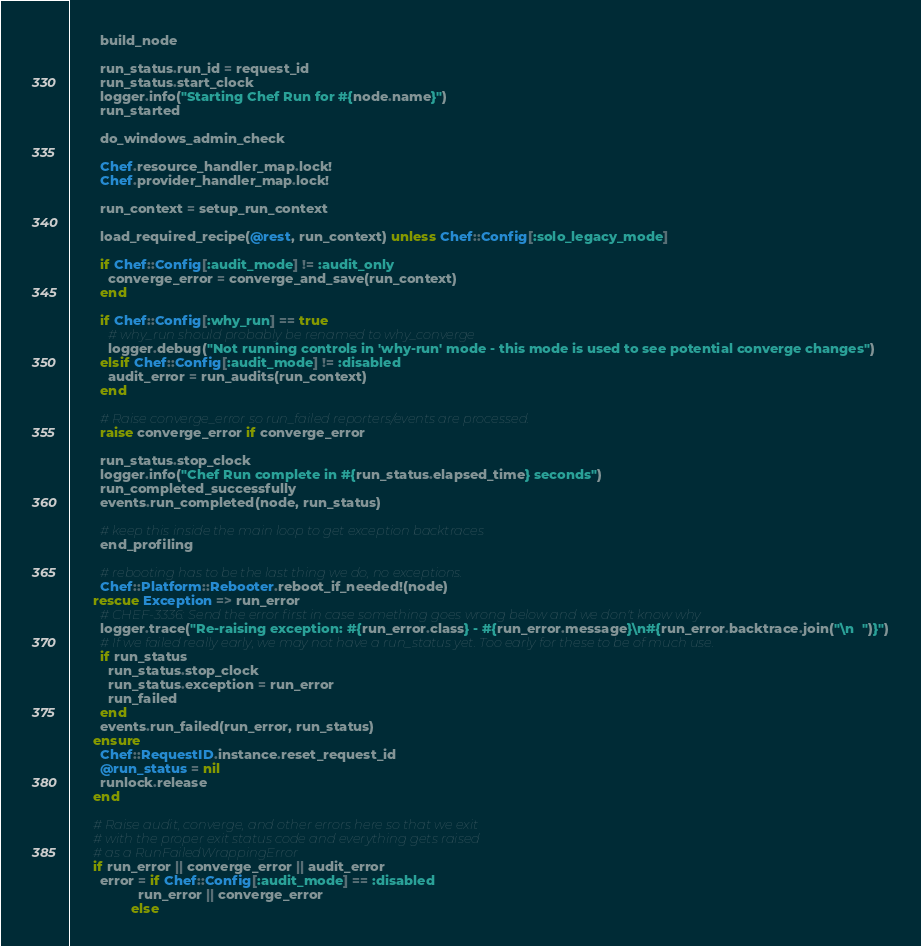Convert code to text. <code><loc_0><loc_0><loc_500><loc_500><_Ruby_>
        build_node

        run_status.run_id = request_id
        run_status.start_clock
        logger.info("Starting Chef Run for #{node.name}")
        run_started

        do_windows_admin_check

        Chef.resource_handler_map.lock!
        Chef.provider_handler_map.lock!

        run_context = setup_run_context

        load_required_recipe(@rest, run_context) unless Chef::Config[:solo_legacy_mode]

        if Chef::Config[:audit_mode] != :audit_only
          converge_error = converge_and_save(run_context)
        end

        if Chef::Config[:why_run] == true
          # why_run should probably be renamed to why_converge
          logger.debug("Not running controls in 'why-run' mode - this mode is used to see potential converge changes")
        elsif Chef::Config[:audit_mode] != :disabled
          audit_error = run_audits(run_context)
        end

        # Raise converge_error so run_failed reporters/events are processed.
        raise converge_error if converge_error

        run_status.stop_clock
        logger.info("Chef Run complete in #{run_status.elapsed_time} seconds")
        run_completed_successfully
        events.run_completed(node, run_status)

        # keep this inside the main loop to get exception backtraces
        end_profiling

        # rebooting has to be the last thing we do, no exceptions.
        Chef::Platform::Rebooter.reboot_if_needed!(node)
      rescue Exception => run_error
        # CHEF-3336: Send the error first in case something goes wrong below and we don't know why
        logger.trace("Re-raising exception: #{run_error.class} - #{run_error.message}\n#{run_error.backtrace.join("\n  ")}")
        # If we failed really early, we may not have a run_status yet. Too early for these to be of much use.
        if run_status
          run_status.stop_clock
          run_status.exception = run_error
          run_failed
        end
        events.run_failed(run_error, run_status)
      ensure
        Chef::RequestID.instance.reset_request_id
        @run_status = nil
        runlock.release
      end

      # Raise audit, converge, and other errors here so that we exit
      # with the proper exit status code and everything gets raised
      # as a RunFailedWrappingError
      if run_error || converge_error || audit_error
        error = if Chef::Config[:audit_mode] == :disabled
                  run_error || converge_error
                else</code> 